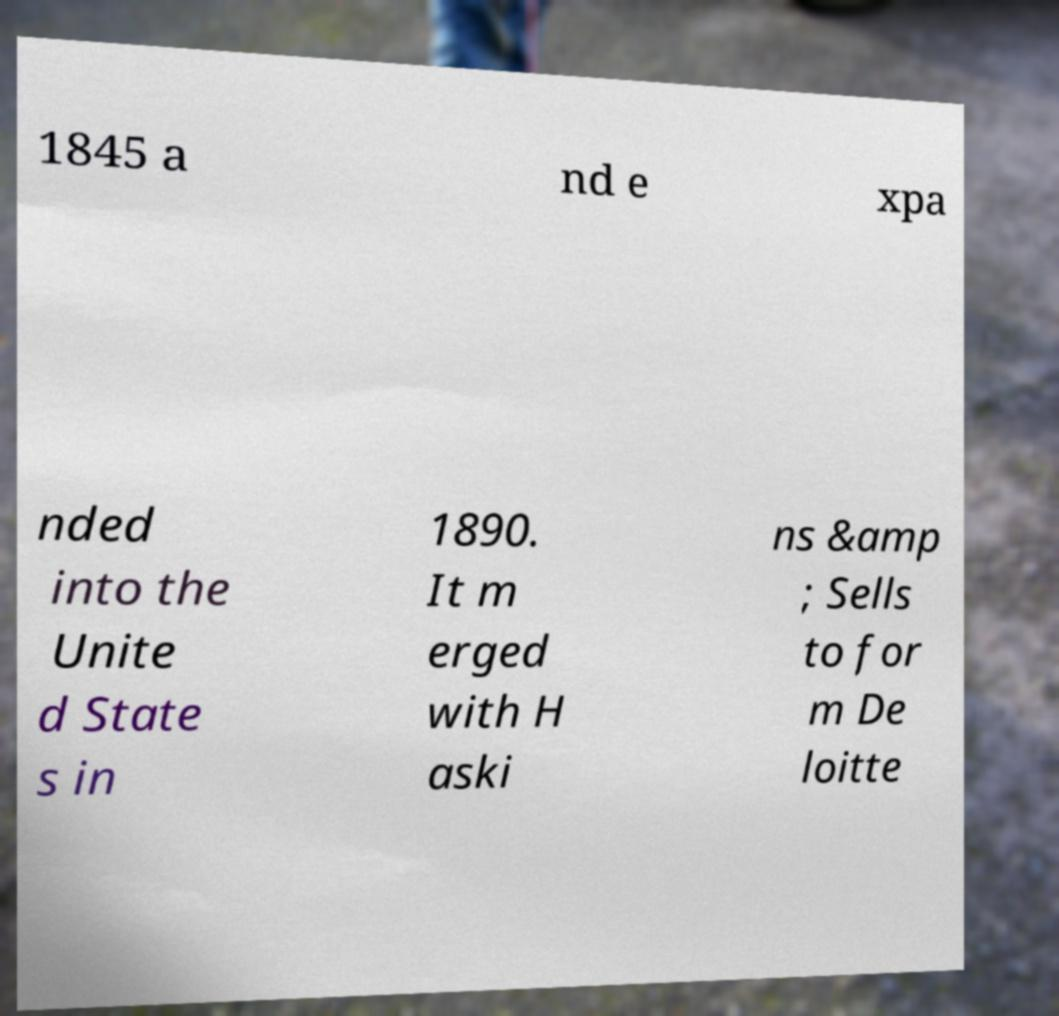There's text embedded in this image that I need extracted. Can you transcribe it verbatim? 1845 a nd e xpa nded into the Unite d State s in 1890. It m erged with H aski ns &amp ; Sells to for m De loitte 